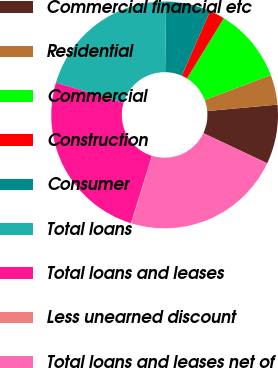<chart> <loc_0><loc_0><loc_500><loc_500><pie_chart><fcel>Commercial financial etc<fcel>Residential<fcel>Commercial<fcel>Construction<fcel>Consumer<fcel>Total loans<fcel>Total loans and leases<fcel>Less unearned discount<fcel>Total loans and leases net of<nl><fcel>8.46%<fcel>4.26%<fcel>10.55%<fcel>2.17%<fcel>6.36%<fcel>20.61%<fcel>24.8%<fcel>0.07%<fcel>22.71%<nl></chart> 